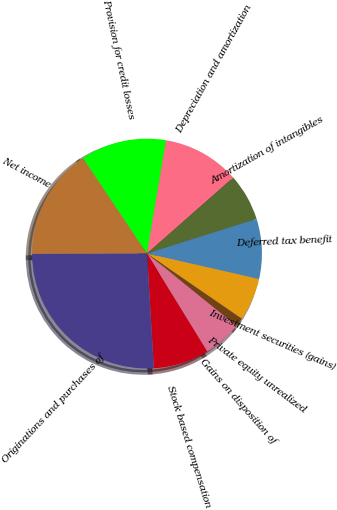Convert chart. <chart><loc_0><loc_0><loc_500><loc_500><pie_chart><fcel>Net income<fcel>Provision for credit losses<fcel>Depreciation and amortization<fcel>Amortization of intangibles<fcel>Deferred tax benefit<fcel>Investment securities (gains)<fcel>Private equity unrealized<fcel>Gains on disposition of<fcel>Stock based compensation<fcel>Originations and purchases of<nl><fcel>15.66%<fcel>12.05%<fcel>10.84%<fcel>6.63%<fcel>8.43%<fcel>6.02%<fcel>1.21%<fcel>5.42%<fcel>7.83%<fcel>25.9%<nl></chart> 